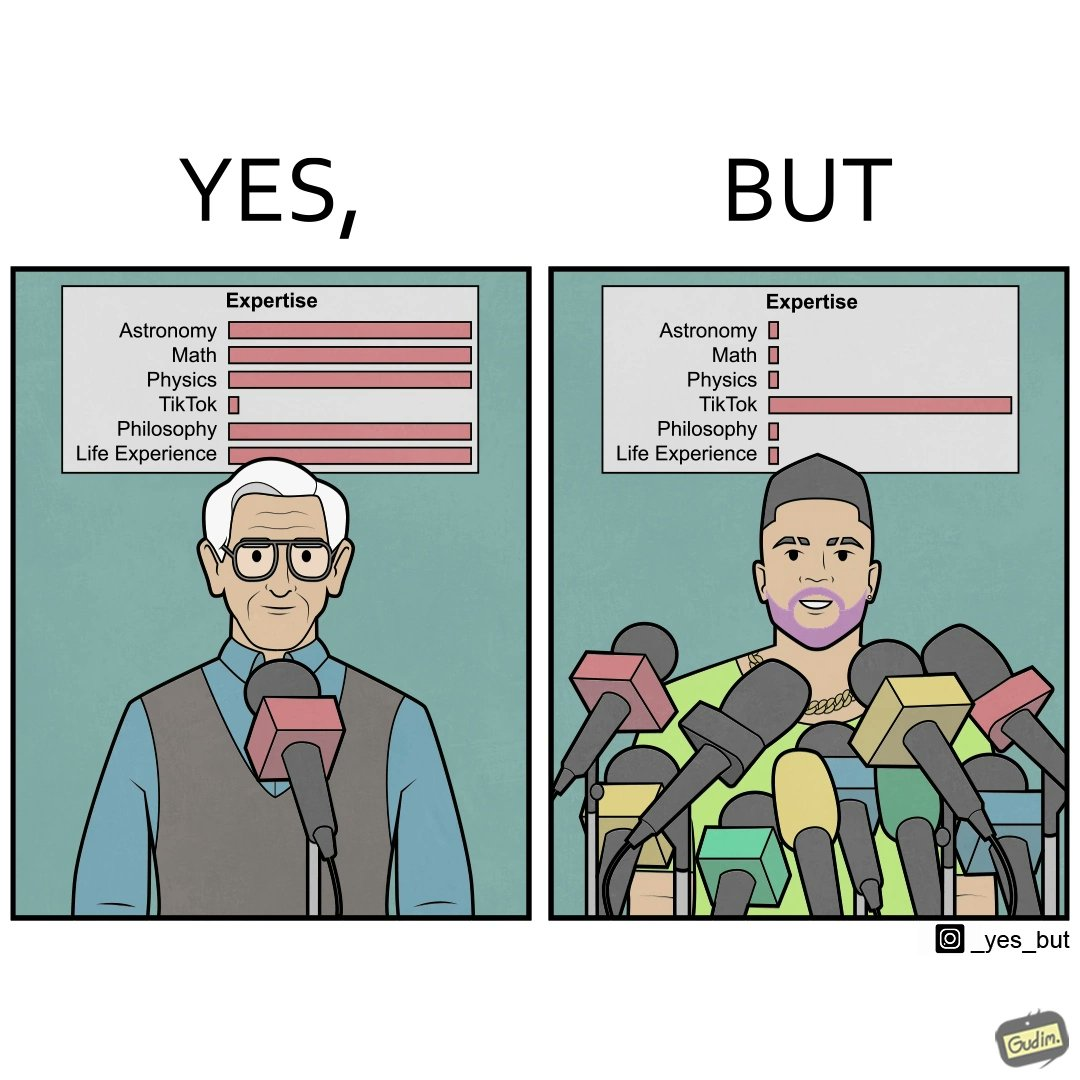What makes this image funny or satirical? The image is satirical beacause it shows that people with more tiktok expertise are treated more importantly than the ones who are expert in all the other areas but tiktok. Here, the number of microphones a man speaks into is indicative of his importance. 